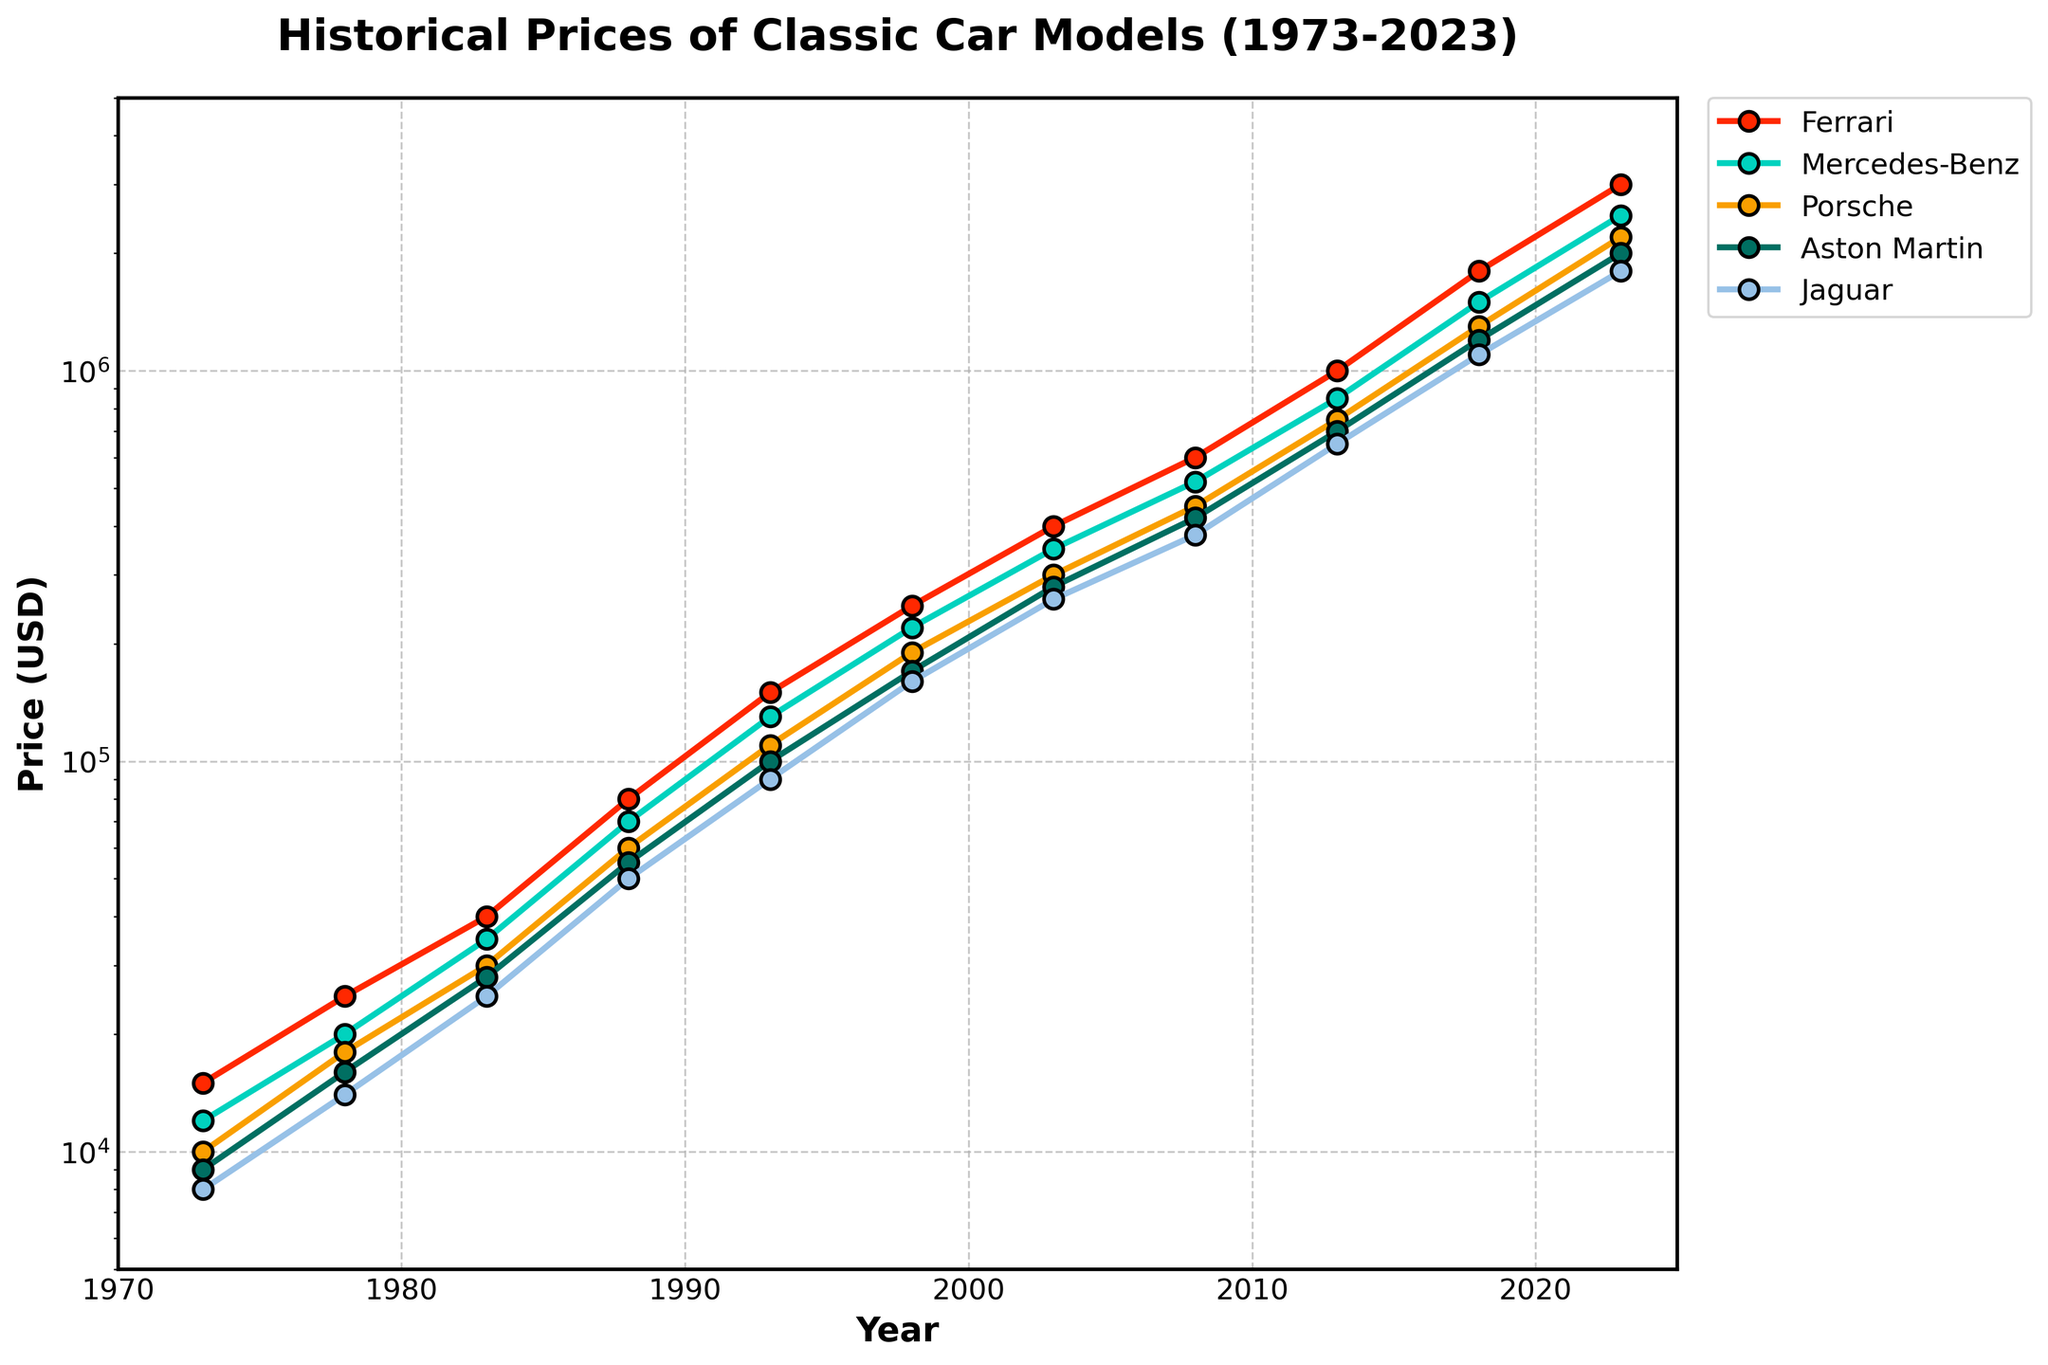What is the overall trend for Ferrari prices from 1973 to 2023? By looking at the line corresponding to Ferrari, we can observe that the prices have consistently increased over the 50-year period. The line goes upward steadily with some steeper inclines in certain periods. This indicates a general trend of increasing value over time.
Answer: Increasing Which brand experienced the highest price in 2023? In 2023, the topmost line on the graph corresponds to Ferrari. According to the y-axis on the right side of the timestamps, Ferrari's value is the highest among all the brands in 2023.
Answer: Ferrari By how much did the price of Mercedes-Benz increase from 1973 to 2023? The price of Mercedes-Benz in 1973 is $12,000, and in 2023 it is $2,500,000. The increase is calculated by subtracting the price in 1973 from the price in 2023: $2,500,000 - $12,000 = $2,488,000.
Answer: $2,488,000 Which brand had the smallest price increase between 1973 and 2023? To find the smallest increase, we need to compare the price differences for all brands between 1973 and 2023. The increases are as follows: Ferrari: $3,000,000 - $15,000 = $2,985,000, Mercedes-Benz: $2,500,000 - $12,000 = $2,488,000, Porsche: $2,200,000 - $10,000 = $2,190,000, Aston Martin: $2,000,000 - $9,000 = $1,991,000, Jaguar: $1,800,000 - $8,000 = $1,792,000. Jaguar has the smallest increase.
Answer: Jaguar Which two brands had nearly equal prices in 2018? In 2018, by observing the lines closely, Mercedes-Benz and Aston Martin show lines that are very close to each other. Checking the y-axis, both these brands had prices around $1,500,000 for Mercedes-Benz and $1,200,000 for Aston Martin.
Answer: Mercedes-Benz and Aston Martin What is the average price of Porsche from 1973 to 2023? To find the average, sum up all the prices for Porsche from 1973 to 2023 and divide by the number of data points (11 years). The prices are: (10000, 18000, 30000, 60000, 110000, 190000, 300000, 450000, 750000, 1300000, 2200000). Sum = 5,020,000. The average is $5,020,000 / 11.
Answer: $456,364 In which period did Aston Martin's price experience the steepest incline? Observing the slope of Aston Martin's line, the steepest increase occurs between 1993 and 1998. The price jumps from $100,000 to $170,000 in these five years, which is the most substantial relative increment.
Answer: 1993-1998 Which brand remained consistently the lowest in value over most of the 50-year period? By looking at the bottom-most line on the graph for the majority of the years, Jaguar appears as the brand with the lowest values compared to the other brands. It only starts closing the gap from 2008 onwards.
Answer: Jaguar How do the growth rates of Ferrari and Porsche compare between 2008 and 2023? The price for Ferrari in 2008 is $600,000 and in 2023 it is $3,000,000, giving an increase of $2,400,000. For Porsche, in 2008 it is $450,000 and in 2023 it is $2,200,000, giving an increase of $1,750,000. Ferrari's growth rate outpaces Porsche during this period.
Answer: Ferrari grows faster 